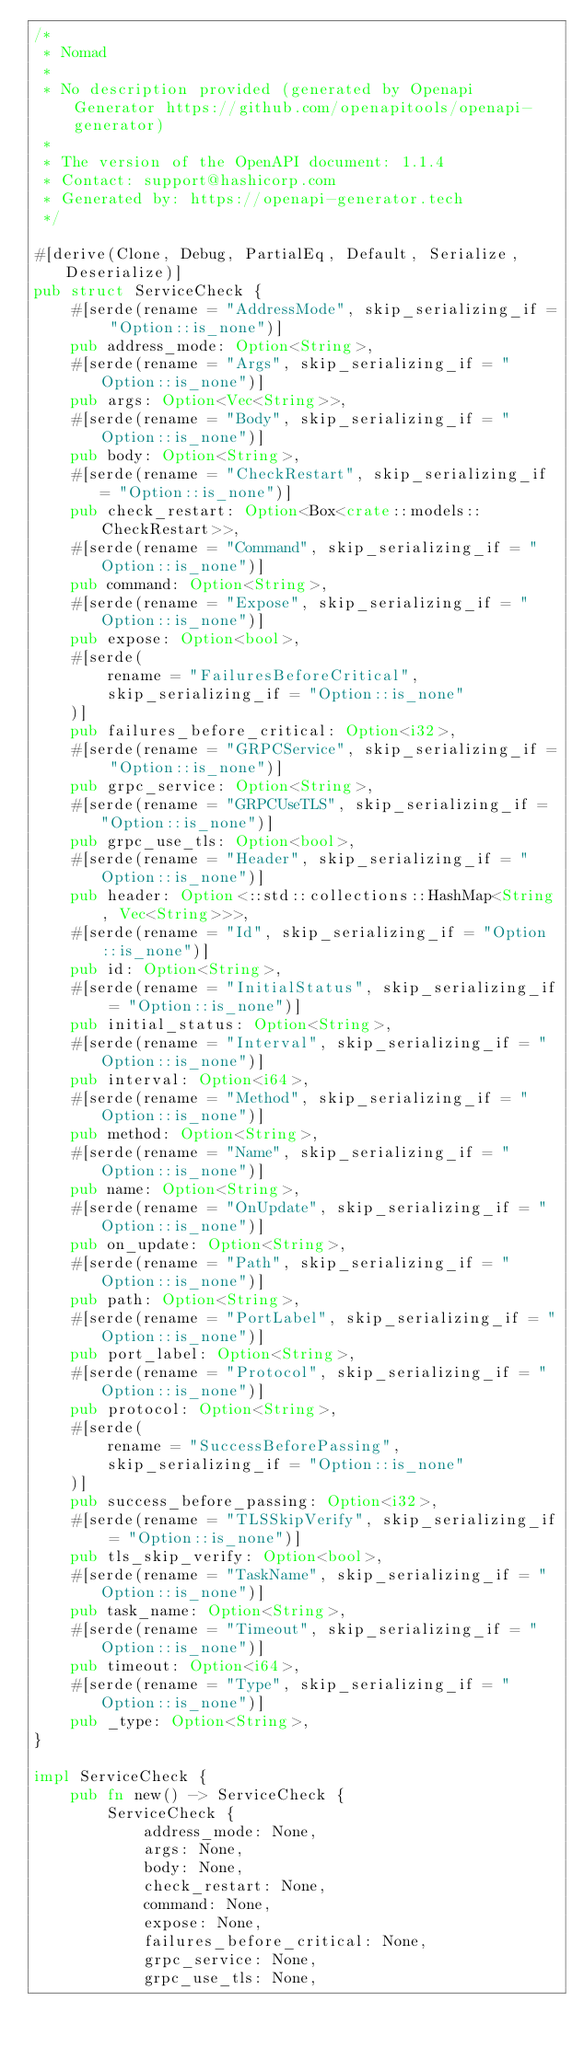<code> <loc_0><loc_0><loc_500><loc_500><_Rust_>/*
 * Nomad
 *
 * No description provided (generated by Openapi Generator https://github.com/openapitools/openapi-generator)
 *
 * The version of the OpenAPI document: 1.1.4
 * Contact: support@hashicorp.com
 * Generated by: https://openapi-generator.tech
 */

#[derive(Clone, Debug, PartialEq, Default, Serialize, Deserialize)]
pub struct ServiceCheck {
    #[serde(rename = "AddressMode", skip_serializing_if = "Option::is_none")]
    pub address_mode: Option<String>,
    #[serde(rename = "Args", skip_serializing_if = "Option::is_none")]
    pub args: Option<Vec<String>>,
    #[serde(rename = "Body", skip_serializing_if = "Option::is_none")]
    pub body: Option<String>,
    #[serde(rename = "CheckRestart", skip_serializing_if = "Option::is_none")]
    pub check_restart: Option<Box<crate::models::CheckRestart>>,
    #[serde(rename = "Command", skip_serializing_if = "Option::is_none")]
    pub command: Option<String>,
    #[serde(rename = "Expose", skip_serializing_if = "Option::is_none")]
    pub expose: Option<bool>,
    #[serde(
        rename = "FailuresBeforeCritical",
        skip_serializing_if = "Option::is_none"
    )]
    pub failures_before_critical: Option<i32>,
    #[serde(rename = "GRPCService", skip_serializing_if = "Option::is_none")]
    pub grpc_service: Option<String>,
    #[serde(rename = "GRPCUseTLS", skip_serializing_if = "Option::is_none")]
    pub grpc_use_tls: Option<bool>,
    #[serde(rename = "Header", skip_serializing_if = "Option::is_none")]
    pub header: Option<::std::collections::HashMap<String, Vec<String>>>,
    #[serde(rename = "Id", skip_serializing_if = "Option::is_none")]
    pub id: Option<String>,
    #[serde(rename = "InitialStatus", skip_serializing_if = "Option::is_none")]
    pub initial_status: Option<String>,
    #[serde(rename = "Interval", skip_serializing_if = "Option::is_none")]
    pub interval: Option<i64>,
    #[serde(rename = "Method", skip_serializing_if = "Option::is_none")]
    pub method: Option<String>,
    #[serde(rename = "Name", skip_serializing_if = "Option::is_none")]
    pub name: Option<String>,
    #[serde(rename = "OnUpdate", skip_serializing_if = "Option::is_none")]
    pub on_update: Option<String>,
    #[serde(rename = "Path", skip_serializing_if = "Option::is_none")]
    pub path: Option<String>,
    #[serde(rename = "PortLabel", skip_serializing_if = "Option::is_none")]
    pub port_label: Option<String>,
    #[serde(rename = "Protocol", skip_serializing_if = "Option::is_none")]
    pub protocol: Option<String>,
    #[serde(
        rename = "SuccessBeforePassing",
        skip_serializing_if = "Option::is_none"
    )]
    pub success_before_passing: Option<i32>,
    #[serde(rename = "TLSSkipVerify", skip_serializing_if = "Option::is_none")]
    pub tls_skip_verify: Option<bool>,
    #[serde(rename = "TaskName", skip_serializing_if = "Option::is_none")]
    pub task_name: Option<String>,
    #[serde(rename = "Timeout", skip_serializing_if = "Option::is_none")]
    pub timeout: Option<i64>,
    #[serde(rename = "Type", skip_serializing_if = "Option::is_none")]
    pub _type: Option<String>,
}

impl ServiceCheck {
    pub fn new() -> ServiceCheck {
        ServiceCheck {
            address_mode: None,
            args: None,
            body: None,
            check_restart: None,
            command: None,
            expose: None,
            failures_before_critical: None,
            grpc_service: None,
            grpc_use_tls: None,</code> 